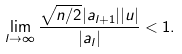<formula> <loc_0><loc_0><loc_500><loc_500>\lim _ { l \rightarrow \infty } \frac { \sqrt { n / 2 } | a _ { l + 1 } | | u | } { | a _ { l } | } < 1 .</formula> 